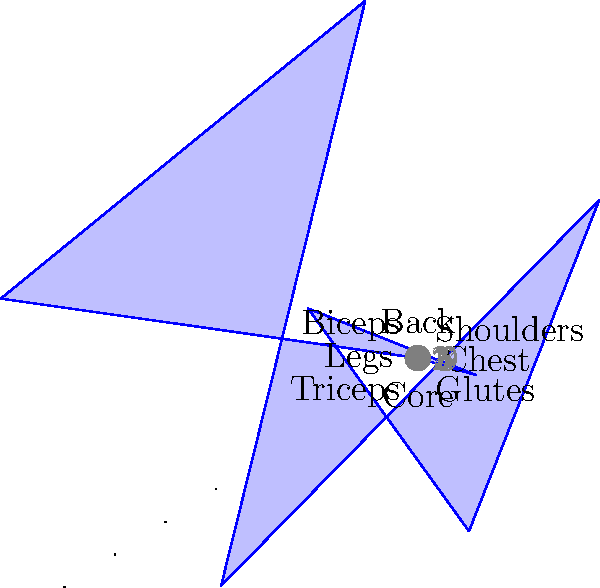As a fitness trainer, you've created a polar coordinate graph to visualize muscle group engagement during a full-body workout. The graph shows 8 muscle groups with engagement levels from 1 to 10. Which muscle group shows the highest engagement level, and what is the difference between the highest and lowest engagement levels? To answer this question, we need to analyze the polar coordinate graph:

1. Identify all muscle groups and their engagement levels:
   - Chest: 8
   - Shoulders: 6
   - Back: 9
   - Biceps: 5
   - Legs: 7
   - Triceps: 4
   - Core: 8
   - Glutes: 3

2. Find the highest engagement level:
   The Back muscle group has the highest engagement level at 9.

3. Find the lowest engagement level:
   The Glutes muscle group has the lowest engagement level at 3.

4. Calculate the difference between the highest and lowest engagement levels:
   $9 - 3 = 6$

Therefore, the Back muscle group shows the highest engagement level, and the difference between the highest (Back: 9) and lowest (Glutes: 3) engagement levels is 6.
Answer: Back; 6 